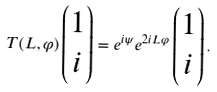<formula> <loc_0><loc_0><loc_500><loc_500>T ( L , \varphi ) \begin{pmatrix} 1 \\ i \end{pmatrix} = e ^ { i \psi } e ^ { 2 i L \varphi } \begin{pmatrix} 1 \\ i \end{pmatrix} .</formula> 